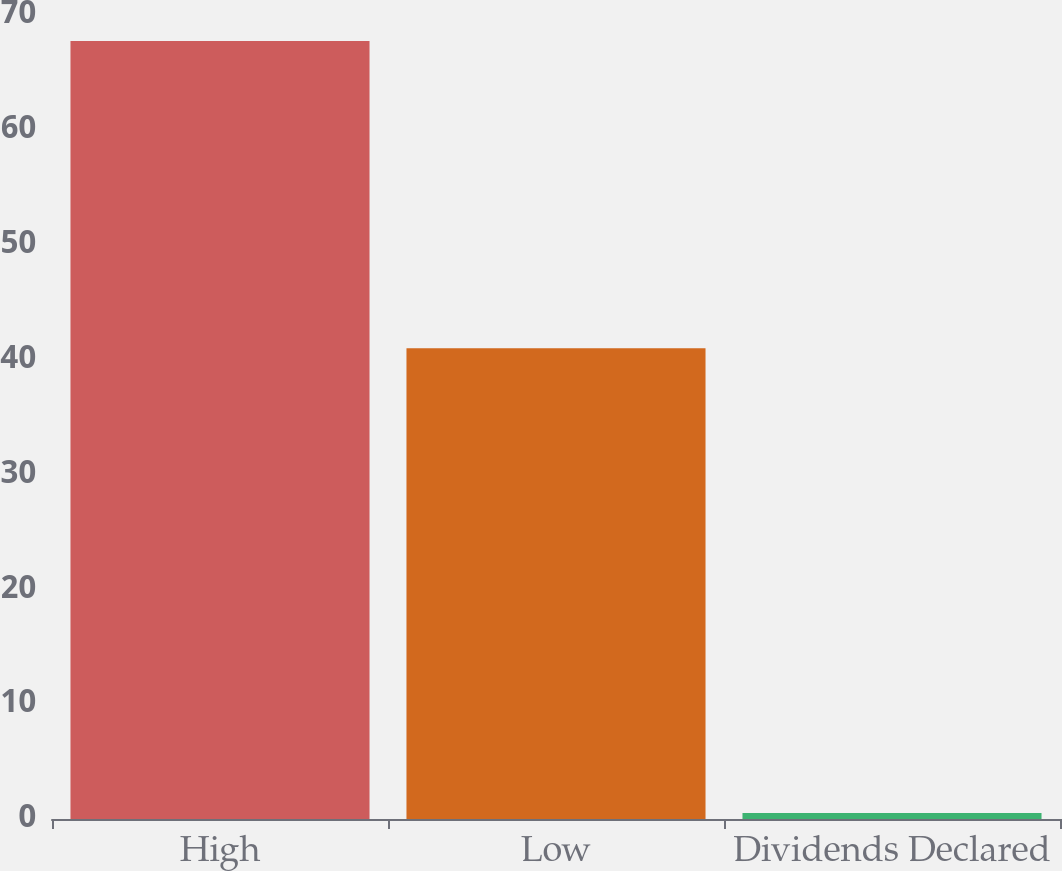Convert chart to OTSL. <chart><loc_0><loc_0><loc_500><loc_500><bar_chart><fcel>High<fcel>Low<fcel>Dividends Declared<nl><fcel>67.74<fcel>40.99<fcel>0.53<nl></chart> 